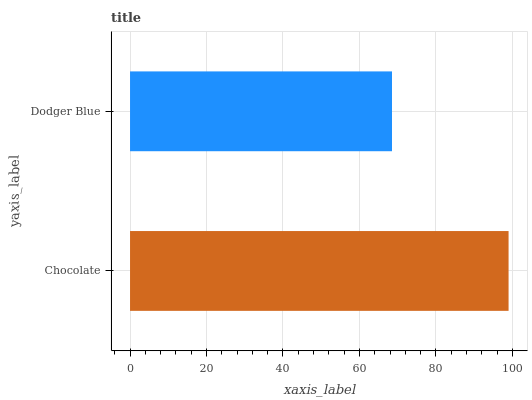Is Dodger Blue the minimum?
Answer yes or no. Yes. Is Chocolate the maximum?
Answer yes or no. Yes. Is Dodger Blue the maximum?
Answer yes or no. No. Is Chocolate greater than Dodger Blue?
Answer yes or no. Yes. Is Dodger Blue less than Chocolate?
Answer yes or no. Yes. Is Dodger Blue greater than Chocolate?
Answer yes or no. No. Is Chocolate less than Dodger Blue?
Answer yes or no. No. Is Chocolate the high median?
Answer yes or no. Yes. Is Dodger Blue the low median?
Answer yes or no. Yes. Is Dodger Blue the high median?
Answer yes or no. No. Is Chocolate the low median?
Answer yes or no. No. 